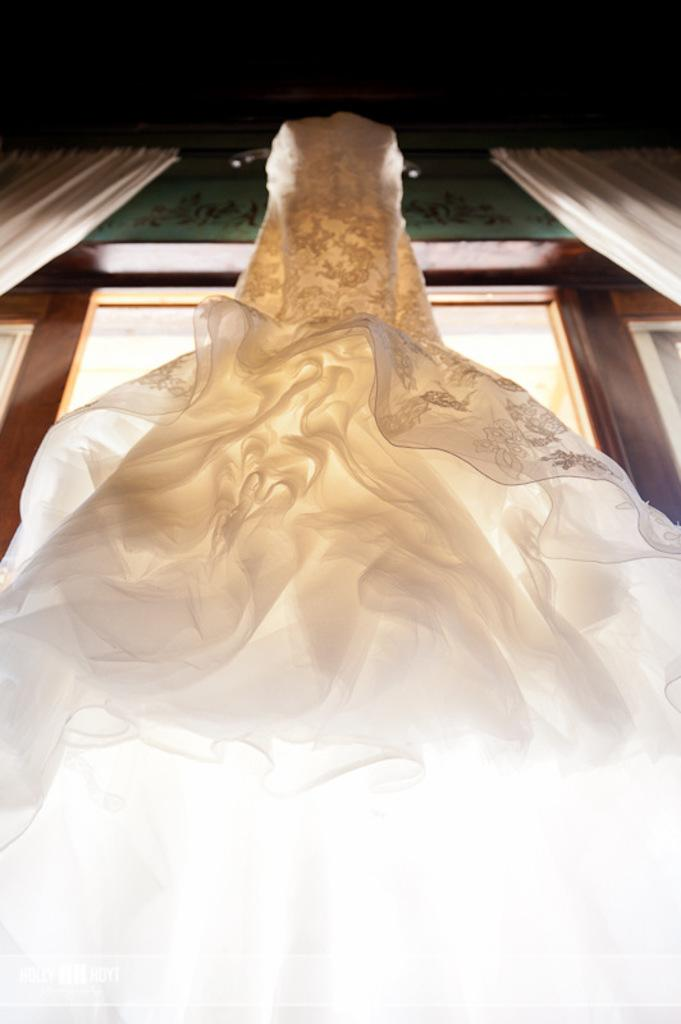What object is present in the image that is made of cloth? There is a cloth in the image. What is visible behind the cloth in the image? There is a window visible behind the cloth in the image. What type of discussion is taking place in the image? There is no discussion present in the image; it only features a cloth and a window. How many tomatoes can be seen on the edge of the cloth in the image? There are no tomatoes present in the image. 